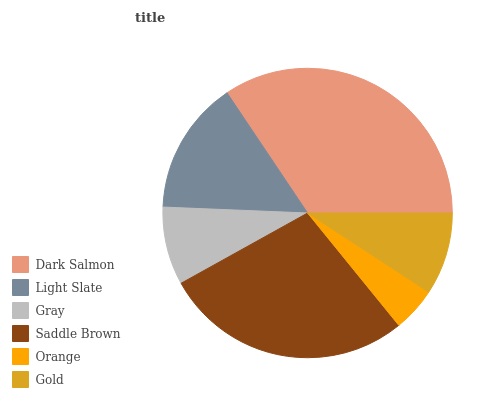Is Orange the minimum?
Answer yes or no. Yes. Is Dark Salmon the maximum?
Answer yes or no. Yes. Is Light Slate the minimum?
Answer yes or no. No. Is Light Slate the maximum?
Answer yes or no. No. Is Dark Salmon greater than Light Slate?
Answer yes or no. Yes. Is Light Slate less than Dark Salmon?
Answer yes or no. Yes. Is Light Slate greater than Dark Salmon?
Answer yes or no. No. Is Dark Salmon less than Light Slate?
Answer yes or no. No. Is Light Slate the high median?
Answer yes or no. Yes. Is Gold the low median?
Answer yes or no. Yes. Is Gray the high median?
Answer yes or no. No. Is Orange the low median?
Answer yes or no. No. 